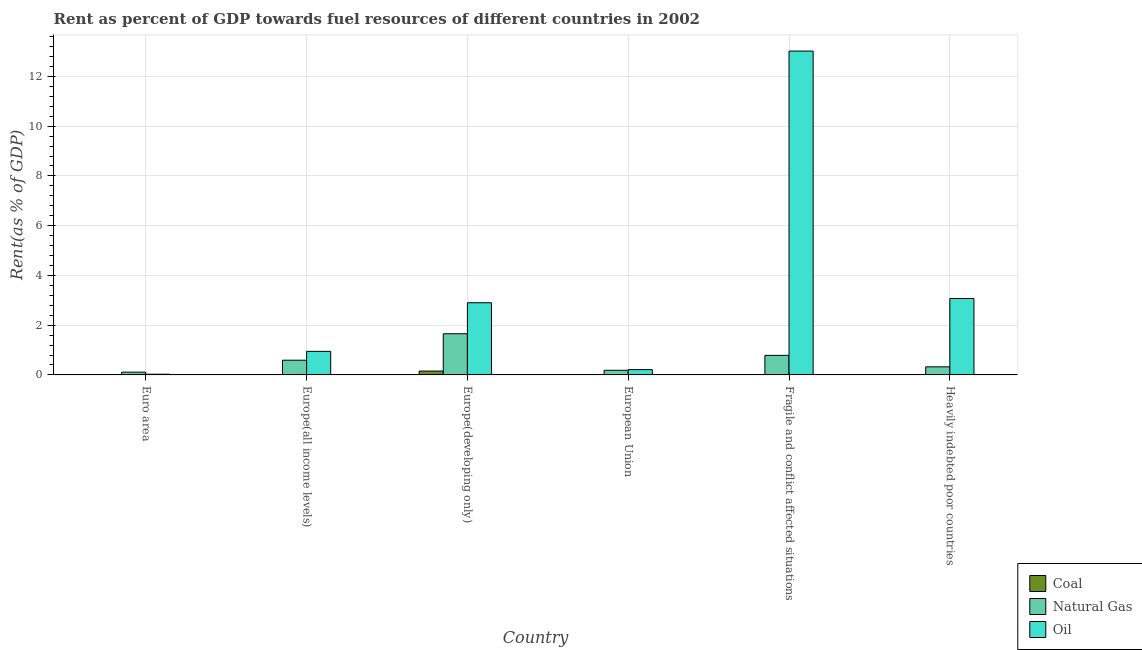How many groups of bars are there?
Your answer should be compact. 6. Are the number of bars per tick equal to the number of legend labels?
Your answer should be very brief. Yes. How many bars are there on the 4th tick from the right?
Your answer should be compact. 3. What is the label of the 3rd group of bars from the left?
Give a very brief answer. Europe(developing only). What is the rent towards natural gas in European Union?
Give a very brief answer. 0.19. Across all countries, what is the maximum rent towards natural gas?
Provide a succinct answer. 1.65. Across all countries, what is the minimum rent towards coal?
Offer a terse response. 5.27895648805611e-5. In which country was the rent towards natural gas maximum?
Offer a terse response. Europe(developing only). In which country was the rent towards natural gas minimum?
Your answer should be compact. Euro area. What is the total rent towards coal in the graph?
Give a very brief answer. 0.17. What is the difference between the rent towards natural gas in Europe(all income levels) and that in Fragile and conflict affected situations?
Your answer should be compact. -0.19. What is the difference between the rent towards oil in European Union and the rent towards natural gas in Europe(all income levels)?
Offer a very short reply. -0.38. What is the average rent towards natural gas per country?
Offer a very short reply. 0.61. What is the difference between the rent towards natural gas and rent towards coal in Heavily indebted poor countries?
Offer a very short reply. 0.32. In how many countries, is the rent towards coal greater than 1.6 %?
Provide a succinct answer. 0. What is the ratio of the rent towards oil in Europe(developing only) to that in Heavily indebted poor countries?
Give a very brief answer. 0.94. What is the difference between the highest and the second highest rent towards coal?
Give a very brief answer. 0.14. What is the difference between the highest and the lowest rent towards oil?
Your response must be concise. 12.99. In how many countries, is the rent towards oil greater than the average rent towards oil taken over all countries?
Offer a terse response. 1. Is the sum of the rent towards natural gas in Euro area and Europe(developing only) greater than the maximum rent towards oil across all countries?
Ensure brevity in your answer.  No. What does the 1st bar from the left in European Union represents?
Your answer should be very brief. Coal. What does the 2nd bar from the right in Euro area represents?
Offer a terse response. Natural Gas. Are all the bars in the graph horizontal?
Your response must be concise. No. How many countries are there in the graph?
Make the answer very short. 6. What is the difference between two consecutive major ticks on the Y-axis?
Provide a succinct answer. 2. Does the graph contain grids?
Offer a very short reply. Yes. How many legend labels are there?
Offer a terse response. 3. What is the title of the graph?
Provide a succinct answer. Rent as percent of GDP towards fuel resources of different countries in 2002. What is the label or title of the X-axis?
Your answer should be very brief. Country. What is the label or title of the Y-axis?
Keep it short and to the point. Rent(as % of GDP). What is the Rent(as % of GDP) in Coal in Euro area?
Make the answer very short. 0. What is the Rent(as % of GDP) in Natural Gas in Euro area?
Keep it short and to the point. 0.11. What is the Rent(as % of GDP) in Oil in Euro area?
Give a very brief answer. 0.03. What is the Rent(as % of GDP) in Coal in Europe(all income levels)?
Offer a terse response. 0.02. What is the Rent(as % of GDP) in Natural Gas in Europe(all income levels)?
Offer a terse response. 0.59. What is the Rent(as % of GDP) of Oil in Europe(all income levels)?
Your response must be concise. 0.95. What is the Rent(as % of GDP) of Coal in Europe(developing only)?
Ensure brevity in your answer.  0.15. What is the Rent(as % of GDP) in Natural Gas in Europe(developing only)?
Offer a very short reply. 1.65. What is the Rent(as % of GDP) of Oil in Europe(developing only)?
Provide a short and direct response. 2.9. What is the Rent(as % of GDP) in Coal in European Union?
Ensure brevity in your answer.  0. What is the Rent(as % of GDP) in Natural Gas in European Union?
Your answer should be very brief. 0.19. What is the Rent(as % of GDP) of Oil in European Union?
Ensure brevity in your answer.  0.21. What is the Rent(as % of GDP) of Coal in Fragile and conflict affected situations?
Your answer should be compact. 5.480222970782129e-5. What is the Rent(as % of GDP) of Natural Gas in Fragile and conflict affected situations?
Your answer should be compact. 0.79. What is the Rent(as % of GDP) of Oil in Fragile and conflict affected situations?
Keep it short and to the point. 13.02. What is the Rent(as % of GDP) of Coal in Heavily indebted poor countries?
Offer a terse response. 5.27895648805611e-5. What is the Rent(as % of GDP) in Natural Gas in Heavily indebted poor countries?
Provide a short and direct response. 0.32. What is the Rent(as % of GDP) in Oil in Heavily indebted poor countries?
Provide a short and direct response. 3.07. Across all countries, what is the maximum Rent(as % of GDP) in Coal?
Keep it short and to the point. 0.15. Across all countries, what is the maximum Rent(as % of GDP) in Natural Gas?
Offer a terse response. 1.65. Across all countries, what is the maximum Rent(as % of GDP) in Oil?
Give a very brief answer. 13.02. Across all countries, what is the minimum Rent(as % of GDP) in Coal?
Your answer should be very brief. 5.27895648805611e-5. Across all countries, what is the minimum Rent(as % of GDP) of Natural Gas?
Offer a terse response. 0.11. Across all countries, what is the minimum Rent(as % of GDP) in Oil?
Give a very brief answer. 0.03. What is the total Rent(as % of GDP) in Coal in the graph?
Make the answer very short. 0.17. What is the total Rent(as % of GDP) in Natural Gas in the graph?
Ensure brevity in your answer.  3.65. What is the total Rent(as % of GDP) in Oil in the graph?
Offer a very short reply. 20.18. What is the difference between the Rent(as % of GDP) in Coal in Euro area and that in Europe(all income levels)?
Your answer should be compact. -0.02. What is the difference between the Rent(as % of GDP) of Natural Gas in Euro area and that in Europe(all income levels)?
Provide a short and direct response. -0.48. What is the difference between the Rent(as % of GDP) of Oil in Euro area and that in Europe(all income levels)?
Keep it short and to the point. -0.92. What is the difference between the Rent(as % of GDP) in Coal in Euro area and that in Europe(developing only)?
Your answer should be compact. -0.15. What is the difference between the Rent(as % of GDP) in Natural Gas in Euro area and that in Europe(developing only)?
Provide a short and direct response. -1.54. What is the difference between the Rent(as % of GDP) in Oil in Euro area and that in Europe(developing only)?
Your answer should be very brief. -2.87. What is the difference between the Rent(as % of GDP) in Natural Gas in Euro area and that in European Union?
Give a very brief answer. -0.07. What is the difference between the Rent(as % of GDP) in Oil in Euro area and that in European Union?
Offer a very short reply. -0.19. What is the difference between the Rent(as % of GDP) of Coal in Euro area and that in Fragile and conflict affected situations?
Make the answer very short. 0. What is the difference between the Rent(as % of GDP) of Natural Gas in Euro area and that in Fragile and conflict affected situations?
Give a very brief answer. -0.67. What is the difference between the Rent(as % of GDP) in Oil in Euro area and that in Fragile and conflict affected situations?
Offer a very short reply. -12.99. What is the difference between the Rent(as % of GDP) of Coal in Euro area and that in Heavily indebted poor countries?
Your response must be concise. 0. What is the difference between the Rent(as % of GDP) in Natural Gas in Euro area and that in Heavily indebted poor countries?
Provide a succinct answer. -0.21. What is the difference between the Rent(as % of GDP) of Oil in Euro area and that in Heavily indebted poor countries?
Give a very brief answer. -3.05. What is the difference between the Rent(as % of GDP) in Coal in Europe(all income levels) and that in Europe(developing only)?
Your answer should be very brief. -0.14. What is the difference between the Rent(as % of GDP) of Natural Gas in Europe(all income levels) and that in Europe(developing only)?
Keep it short and to the point. -1.06. What is the difference between the Rent(as % of GDP) of Oil in Europe(all income levels) and that in Europe(developing only)?
Ensure brevity in your answer.  -1.95. What is the difference between the Rent(as % of GDP) in Coal in Europe(all income levels) and that in European Union?
Keep it short and to the point. 0.02. What is the difference between the Rent(as % of GDP) in Natural Gas in Europe(all income levels) and that in European Union?
Provide a short and direct response. 0.41. What is the difference between the Rent(as % of GDP) in Oil in Europe(all income levels) and that in European Union?
Keep it short and to the point. 0.73. What is the difference between the Rent(as % of GDP) in Coal in Europe(all income levels) and that in Fragile and conflict affected situations?
Offer a terse response. 0.02. What is the difference between the Rent(as % of GDP) in Natural Gas in Europe(all income levels) and that in Fragile and conflict affected situations?
Offer a terse response. -0.19. What is the difference between the Rent(as % of GDP) in Oil in Europe(all income levels) and that in Fragile and conflict affected situations?
Make the answer very short. -12.07. What is the difference between the Rent(as % of GDP) of Coal in Europe(all income levels) and that in Heavily indebted poor countries?
Offer a terse response. 0.02. What is the difference between the Rent(as % of GDP) in Natural Gas in Europe(all income levels) and that in Heavily indebted poor countries?
Your answer should be compact. 0.27. What is the difference between the Rent(as % of GDP) of Oil in Europe(all income levels) and that in Heavily indebted poor countries?
Offer a terse response. -2.13. What is the difference between the Rent(as % of GDP) in Coal in Europe(developing only) and that in European Union?
Offer a very short reply. 0.15. What is the difference between the Rent(as % of GDP) of Natural Gas in Europe(developing only) and that in European Union?
Offer a terse response. 1.47. What is the difference between the Rent(as % of GDP) of Oil in Europe(developing only) and that in European Union?
Offer a terse response. 2.69. What is the difference between the Rent(as % of GDP) in Coal in Europe(developing only) and that in Fragile and conflict affected situations?
Give a very brief answer. 0.15. What is the difference between the Rent(as % of GDP) in Natural Gas in Europe(developing only) and that in Fragile and conflict affected situations?
Keep it short and to the point. 0.87. What is the difference between the Rent(as % of GDP) in Oil in Europe(developing only) and that in Fragile and conflict affected situations?
Make the answer very short. -10.12. What is the difference between the Rent(as % of GDP) in Coal in Europe(developing only) and that in Heavily indebted poor countries?
Your answer should be compact. 0.15. What is the difference between the Rent(as % of GDP) in Natural Gas in Europe(developing only) and that in Heavily indebted poor countries?
Your answer should be compact. 1.33. What is the difference between the Rent(as % of GDP) in Oil in Europe(developing only) and that in Heavily indebted poor countries?
Offer a terse response. -0.17. What is the difference between the Rent(as % of GDP) of Coal in European Union and that in Fragile and conflict affected situations?
Your answer should be very brief. 0. What is the difference between the Rent(as % of GDP) of Natural Gas in European Union and that in Fragile and conflict affected situations?
Your answer should be compact. -0.6. What is the difference between the Rent(as % of GDP) in Oil in European Union and that in Fragile and conflict affected situations?
Make the answer very short. -12.81. What is the difference between the Rent(as % of GDP) of Natural Gas in European Union and that in Heavily indebted poor countries?
Offer a terse response. -0.14. What is the difference between the Rent(as % of GDP) in Oil in European Union and that in Heavily indebted poor countries?
Offer a very short reply. -2.86. What is the difference between the Rent(as % of GDP) of Coal in Fragile and conflict affected situations and that in Heavily indebted poor countries?
Give a very brief answer. 0. What is the difference between the Rent(as % of GDP) in Natural Gas in Fragile and conflict affected situations and that in Heavily indebted poor countries?
Provide a short and direct response. 0.46. What is the difference between the Rent(as % of GDP) in Oil in Fragile and conflict affected situations and that in Heavily indebted poor countries?
Give a very brief answer. 9.95. What is the difference between the Rent(as % of GDP) in Coal in Euro area and the Rent(as % of GDP) in Natural Gas in Europe(all income levels)?
Your answer should be compact. -0.59. What is the difference between the Rent(as % of GDP) in Coal in Euro area and the Rent(as % of GDP) in Oil in Europe(all income levels)?
Provide a short and direct response. -0.95. What is the difference between the Rent(as % of GDP) in Natural Gas in Euro area and the Rent(as % of GDP) in Oil in Europe(all income levels)?
Give a very brief answer. -0.84. What is the difference between the Rent(as % of GDP) of Coal in Euro area and the Rent(as % of GDP) of Natural Gas in Europe(developing only)?
Provide a short and direct response. -1.65. What is the difference between the Rent(as % of GDP) of Coal in Euro area and the Rent(as % of GDP) of Oil in Europe(developing only)?
Ensure brevity in your answer.  -2.9. What is the difference between the Rent(as % of GDP) in Natural Gas in Euro area and the Rent(as % of GDP) in Oil in Europe(developing only)?
Offer a very short reply. -2.79. What is the difference between the Rent(as % of GDP) in Coal in Euro area and the Rent(as % of GDP) in Natural Gas in European Union?
Keep it short and to the point. -0.19. What is the difference between the Rent(as % of GDP) in Coal in Euro area and the Rent(as % of GDP) in Oil in European Union?
Provide a succinct answer. -0.21. What is the difference between the Rent(as % of GDP) in Natural Gas in Euro area and the Rent(as % of GDP) in Oil in European Union?
Offer a very short reply. -0.1. What is the difference between the Rent(as % of GDP) of Coal in Euro area and the Rent(as % of GDP) of Natural Gas in Fragile and conflict affected situations?
Ensure brevity in your answer.  -0.79. What is the difference between the Rent(as % of GDP) in Coal in Euro area and the Rent(as % of GDP) in Oil in Fragile and conflict affected situations?
Your answer should be compact. -13.02. What is the difference between the Rent(as % of GDP) in Natural Gas in Euro area and the Rent(as % of GDP) in Oil in Fragile and conflict affected situations?
Ensure brevity in your answer.  -12.91. What is the difference between the Rent(as % of GDP) in Coal in Euro area and the Rent(as % of GDP) in Natural Gas in Heavily indebted poor countries?
Keep it short and to the point. -0.32. What is the difference between the Rent(as % of GDP) in Coal in Euro area and the Rent(as % of GDP) in Oil in Heavily indebted poor countries?
Ensure brevity in your answer.  -3.07. What is the difference between the Rent(as % of GDP) of Natural Gas in Euro area and the Rent(as % of GDP) of Oil in Heavily indebted poor countries?
Provide a succinct answer. -2.96. What is the difference between the Rent(as % of GDP) in Coal in Europe(all income levels) and the Rent(as % of GDP) in Natural Gas in Europe(developing only)?
Keep it short and to the point. -1.64. What is the difference between the Rent(as % of GDP) in Coal in Europe(all income levels) and the Rent(as % of GDP) in Oil in Europe(developing only)?
Your answer should be compact. -2.88. What is the difference between the Rent(as % of GDP) of Natural Gas in Europe(all income levels) and the Rent(as % of GDP) of Oil in Europe(developing only)?
Make the answer very short. -2.31. What is the difference between the Rent(as % of GDP) of Coal in Europe(all income levels) and the Rent(as % of GDP) of Natural Gas in European Union?
Provide a succinct answer. -0.17. What is the difference between the Rent(as % of GDP) of Coal in Europe(all income levels) and the Rent(as % of GDP) of Oil in European Union?
Offer a very short reply. -0.2. What is the difference between the Rent(as % of GDP) of Natural Gas in Europe(all income levels) and the Rent(as % of GDP) of Oil in European Union?
Give a very brief answer. 0.38. What is the difference between the Rent(as % of GDP) of Coal in Europe(all income levels) and the Rent(as % of GDP) of Natural Gas in Fragile and conflict affected situations?
Your answer should be very brief. -0.77. What is the difference between the Rent(as % of GDP) in Coal in Europe(all income levels) and the Rent(as % of GDP) in Oil in Fragile and conflict affected situations?
Ensure brevity in your answer.  -13. What is the difference between the Rent(as % of GDP) in Natural Gas in Europe(all income levels) and the Rent(as % of GDP) in Oil in Fragile and conflict affected situations?
Your response must be concise. -12.43. What is the difference between the Rent(as % of GDP) of Coal in Europe(all income levels) and the Rent(as % of GDP) of Natural Gas in Heavily indebted poor countries?
Offer a terse response. -0.31. What is the difference between the Rent(as % of GDP) of Coal in Europe(all income levels) and the Rent(as % of GDP) of Oil in Heavily indebted poor countries?
Ensure brevity in your answer.  -3.06. What is the difference between the Rent(as % of GDP) of Natural Gas in Europe(all income levels) and the Rent(as % of GDP) of Oil in Heavily indebted poor countries?
Your answer should be compact. -2.48. What is the difference between the Rent(as % of GDP) in Coal in Europe(developing only) and the Rent(as % of GDP) in Natural Gas in European Union?
Offer a very short reply. -0.03. What is the difference between the Rent(as % of GDP) of Coal in Europe(developing only) and the Rent(as % of GDP) of Oil in European Union?
Provide a short and direct response. -0.06. What is the difference between the Rent(as % of GDP) of Natural Gas in Europe(developing only) and the Rent(as % of GDP) of Oil in European Union?
Ensure brevity in your answer.  1.44. What is the difference between the Rent(as % of GDP) in Coal in Europe(developing only) and the Rent(as % of GDP) in Natural Gas in Fragile and conflict affected situations?
Ensure brevity in your answer.  -0.63. What is the difference between the Rent(as % of GDP) of Coal in Europe(developing only) and the Rent(as % of GDP) of Oil in Fragile and conflict affected situations?
Give a very brief answer. -12.86. What is the difference between the Rent(as % of GDP) of Natural Gas in Europe(developing only) and the Rent(as % of GDP) of Oil in Fragile and conflict affected situations?
Offer a terse response. -11.36. What is the difference between the Rent(as % of GDP) of Coal in Europe(developing only) and the Rent(as % of GDP) of Natural Gas in Heavily indebted poor countries?
Ensure brevity in your answer.  -0.17. What is the difference between the Rent(as % of GDP) of Coal in Europe(developing only) and the Rent(as % of GDP) of Oil in Heavily indebted poor countries?
Give a very brief answer. -2.92. What is the difference between the Rent(as % of GDP) in Natural Gas in Europe(developing only) and the Rent(as % of GDP) in Oil in Heavily indebted poor countries?
Make the answer very short. -1.42. What is the difference between the Rent(as % of GDP) of Coal in European Union and the Rent(as % of GDP) of Natural Gas in Fragile and conflict affected situations?
Your response must be concise. -0.79. What is the difference between the Rent(as % of GDP) of Coal in European Union and the Rent(as % of GDP) of Oil in Fragile and conflict affected situations?
Make the answer very short. -13.02. What is the difference between the Rent(as % of GDP) in Natural Gas in European Union and the Rent(as % of GDP) in Oil in Fragile and conflict affected situations?
Offer a terse response. -12.83. What is the difference between the Rent(as % of GDP) in Coal in European Union and the Rent(as % of GDP) in Natural Gas in Heavily indebted poor countries?
Give a very brief answer. -0.32. What is the difference between the Rent(as % of GDP) of Coal in European Union and the Rent(as % of GDP) of Oil in Heavily indebted poor countries?
Ensure brevity in your answer.  -3.07. What is the difference between the Rent(as % of GDP) in Natural Gas in European Union and the Rent(as % of GDP) in Oil in Heavily indebted poor countries?
Give a very brief answer. -2.89. What is the difference between the Rent(as % of GDP) of Coal in Fragile and conflict affected situations and the Rent(as % of GDP) of Natural Gas in Heavily indebted poor countries?
Offer a very short reply. -0.32. What is the difference between the Rent(as % of GDP) of Coal in Fragile and conflict affected situations and the Rent(as % of GDP) of Oil in Heavily indebted poor countries?
Offer a terse response. -3.07. What is the difference between the Rent(as % of GDP) in Natural Gas in Fragile and conflict affected situations and the Rent(as % of GDP) in Oil in Heavily indebted poor countries?
Offer a terse response. -2.29. What is the average Rent(as % of GDP) of Coal per country?
Keep it short and to the point. 0.03. What is the average Rent(as % of GDP) in Natural Gas per country?
Your answer should be very brief. 0.61. What is the average Rent(as % of GDP) of Oil per country?
Your answer should be compact. 3.36. What is the difference between the Rent(as % of GDP) of Coal and Rent(as % of GDP) of Natural Gas in Euro area?
Offer a very short reply. -0.11. What is the difference between the Rent(as % of GDP) of Coal and Rent(as % of GDP) of Oil in Euro area?
Provide a short and direct response. -0.03. What is the difference between the Rent(as % of GDP) of Natural Gas and Rent(as % of GDP) of Oil in Euro area?
Offer a terse response. 0.08. What is the difference between the Rent(as % of GDP) of Coal and Rent(as % of GDP) of Natural Gas in Europe(all income levels)?
Offer a terse response. -0.57. What is the difference between the Rent(as % of GDP) in Coal and Rent(as % of GDP) in Oil in Europe(all income levels)?
Provide a succinct answer. -0.93. What is the difference between the Rent(as % of GDP) in Natural Gas and Rent(as % of GDP) in Oil in Europe(all income levels)?
Provide a short and direct response. -0.36. What is the difference between the Rent(as % of GDP) of Coal and Rent(as % of GDP) of Natural Gas in Europe(developing only)?
Provide a succinct answer. -1.5. What is the difference between the Rent(as % of GDP) in Coal and Rent(as % of GDP) in Oil in Europe(developing only)?
Offer a terse response. -2.75. What is the difference between the Rent(as % of GDP) in Natural Gas and Rent(as % of GDP) in Oil in Europe(developing only)?
Give a very brief answer. -1.25. What is the difference between the Rent(as % of GDP) in Coal and Rent(as % of GDP) in Natural Gas in European Union?
Provide a succinct answer. -0.19. What is the difference between the Rent(as % of GDP) in Coal and Rent(as % of GDP) in Oil in European Union?
Ensure brevity in your answer.  -0.21. What is the difference between the Rent(as % of GDP) in Natural Gas and Rent(as % of GDP) in Oil in European Union?
Offer a very short reply. -0.03. What is the difference between the Rent(as % of GDP) in Coal and Rent(as % of GDP) in Natural Gas in Fragile and conflict affected situations?
Your response must be concise. -0.79. What is the difference between the Rent(as % of GDP) in Coal and Rent(as % of GDP) in Oil in Fragile and conflict affected situations?
Ensure brevity in your answer.  -13.02. What is the difference between the Rent(as % of GDP) of Natural Gas and Rent(as % of GDP) of Oil in Fragile and conflict affected situations?
Ensure brevity in your answer.  -12.23. What is the difference between the Rent(as % of GDP) of Coal and Rent(as % of GDP) of Natural Gas in Heavily indebted poor countries?
Give a very brief answer. -0.32. What is the difference between the Rent(as % of GDP) of Coal and Rent(as % of GDP) of Oil in Heavily indebted poor countries?
Provide a short and direct response. -3.07. What is the difference between the Rent(as % of GDP) in Natural Gas and Rent(as % of GDP) in Oil in Heavily indebted poor countries?
Provide a short and direct response. -2.75. What is the ratio of the Rent(as % of GDP) of Coal in Euro area to that in Europe(all income levels)?
Offer a terse response. 0.02. What is the ratio of the Rent(as % of GDP) in Natural Gas in Euro area to that in Europe(all income levels)?
Give a very brief answer. 0.19. What is the ratio of the Rent(as % of GDP) in Oil in Euro area to that in Europe(all income levels)?
Your answer should be compact. 0.03. What is the ratio of the Rent(as % of GDP) in Coal in Euro area to that in Europe(developing only)?
Your answer should be compact. 0. What is the ratio of the Rent(as % of GDP) in Natural Gas in Euro area to that in Europe(developing only)?
Offer a very short reply. 0.07. What is the ratio of the Rent(as % of GDP) of Oil in Euro area to that in Europe(developing only)?
Provide a succinct answer. 0.01. What is the ratio of the Rent(as % of GDP) of Coal in Euro area to that in European Union?
Your answer should be very brief. 1.36. What is the ratio of the Rent(as % of GDP) in Natural Gas in Euro area to that in European Union?
Your answer should be compact. 0.6. What is the ratio of the Rent(as % of GDP) of Oil in Euro area to that in European Union?
Your response must be concise. 0.13. What is the ratio of the Rent(as % of GDP) of Coal in Euro area to that in Fragile and conflict affected situations?
Your answer should be very brief. 4.5. What is the ratio of the Rent(as % of GDP) of Natural Gas in Euro area to that in Fragile and conflict affected situations?
Offer a terse response. 0.14. What is the ratio of the Rent(as % of GDP) in Oil in Euro area to that in Fragile and conflict affected situations?
Offer a terse response. 0. What is the ratio of the Rent(as % of GDP) of Coal in Euro area to that in Heavily indebted poor countries?
Provide a short and direct response. 4.67. What is the ratio of the Rent(as % of GDP) in Natural Gas in Euro area to that in Heavily indebted poor countries?
Your response must be concise. 0.34. What is the ratio of the Rent(as % of GDP) in Oil in Euro area to that in Heavily indebted poor countries?
Make the answer very short. 0.01. What is the ratio of the Rent(as % of GDP) of Coal in Europe(all income levels) to that in Europe(developing only)?
Offer a terse response. 0.1. What is the ratio of the Rent(as % of GDP) in Natural Gas in Europe(all income levels) to that in Europe(developing only)?
Make the answer very short. 0.36. What is the ratio of the Rent(as % of GDP) of Oil in Europe(all income levels) to that in Europe(developing only)?
Ensure brevity in your answer.  0.33. What is the ratio of the Rent(as % of GDP) of Coal in Europe(all income levels) to that in European Union?
Give a very brief answer. 87.97. What is the ratio of the Rent(as % of GDP) of Natural Gas in Europe(all income levels) to that in European Union?
Your answer should be very brief. 3.18. What is the ratio of the Rent(as % of GDP) of Oil in Europe(all income levels) to that in European Union?
Give a very brief answer. 4.44. What is the ratio of the Rent(as % of GDP) in Coal in Europe(all income levels) to that in Fragile and conflict affected situations?
Your answer should be very brief. 291.81. What is the ratio of the Rent(as % of GDP) in Natural Gas in Europe(all income levels) to that in Fragile and conflict affected situations?
Ensure brevity in your answer.  0.75. What is the ratio of the Rent(as % of GDP) of Oil in Europe(all income levels) to that in Fragile and conflict affected situations?
Keep it short and to the point. 0.07. What is the ratio of the Rent(as % of GDP) in Coal in Europe(all income levels) to that in Heavily indebted poor countries?
Provide a short and direct response. 302.94. What is the ratio of the Rent(as % of GDP) of Natural Gas in Europe(all income levels) to that in Heavily indebted poor countries?
Your response must be concise. 1.82. What is the ratio of the Rent(as % of GDP) in Oil in Europe(all income levels) to that in Heavily indebted poor countries?
Offer a terse response. 0.31. What is the ratio of the Rent(as % of GDP) in Coal in Europe(developing only) to that in European Union?
Offer a very short reply. 851.57. What is the ratio of the Rent(as % of GDP) of Natural Gas in Europe(developing only) to that in European Union?
Give a very brief answer. 8.92. What is the ratio of the Rent(as % of GDP) of Oil in Europe(developing only) to that in European Union?
Offer a very short reply. 13.61. What is the ratio of the Rent(as % of GDP) of Coal in Europe(developing only) to that in Fragile and conflict affected situations?
Keep it short and to the point. 2824.73. What is the ratio of the Rent(as % of GDP) in Natural Gas in Europe(developing only) to that in Fragile and conflict affected situations?
Offer a very short reply. 2.11. What is the ratio of the Rent(as % of GDP) in Oil in Europe(developing only) to that in Fragile and conflict affected situations?
Ensure brevity in your answer.  0.22. What is the ratio of the Rent(as % of GDP) of Coal in Europe(developing only) to that in Heavily indebted poor countries?
Your answer should be compact. 2932.42. What is the ratio of the Rent(as % of GDP) in Natural Gas in Europe(developing only) to that in Heavily indebted poor countries?
Ensure brevity in your answer.  5.1. What is the ratio of the Rent(as % of GDP) of Oil in Europe(developing only) to that in Heavily indebted poor countries?
Offer a terse response. 0.94. What is the ratio of the Rent(as % of GDP) of Coal in European Union to that in Fragile and conflict affected situations?
Your answer should be compact. 3.32. What is the ratio of the Rent(as % of GDP) in Natural Gas in European Union to that in Fragile and conflict affected situations?
Your answer should be compact. 0.24. What is the ratio of the Rent(as % of GDP) of Oil in European Union to that in Fragile and conflict affected situations?
Offer a terse response. 0.02. What is the ratio of the Rent(as % of GDP) in Coal in European Union to that in Heavily indebted poor countries?
Keep it short and to the point. 3.44. What is the ratio of the Rent(as % of GDP) in Oil in European Union to that in Heavily indebted poor countries?
Keep it short and to the point. 0.07. What is the ratio of the Rent(as % of GDP) in Coal in Fragile and conflict affected situations to that in Heavily indebted poor countries?
Offer a very short reply. 1.04. What is the ratio of the Rent(as % of GDP) in Natural Gas in Fragile and conflict affected situations to that in Heavily indebted poor countries?
Your answer should be very brief. 2.42. What is the ratio of the Rent(as % of GDP) of Oil in Fragile and conflict affected situations to that in Heavily indebted poor countries?
Offer a very short reply. 4.24. What is the difference between the highest and the second highest Rent(as % of GDP) of Coal?
Your answer should be compact. 0.14. What is the difference between the highest and the second highest Rent(as % of GDP) in Natural Gas?
Provide a short and direct response. 0.87. What is the difference between the highest and the second highest Rent(as % of GDP) in Oil?
Offer a very short reply. 9.95. What is the difference between the highest and the lowest Rent(as % of GDP) in Coal?
Keep it short and to the point. 0.15. What is the difference between the highest and the lowest Rent(as % of GDP) of Natural Gas?
Ensure brevity in your answer.  1.54. What is the difference between the highest and the lowest Rent(as % of GDP) of Oil?
Offer a very short reply. 12.99. 